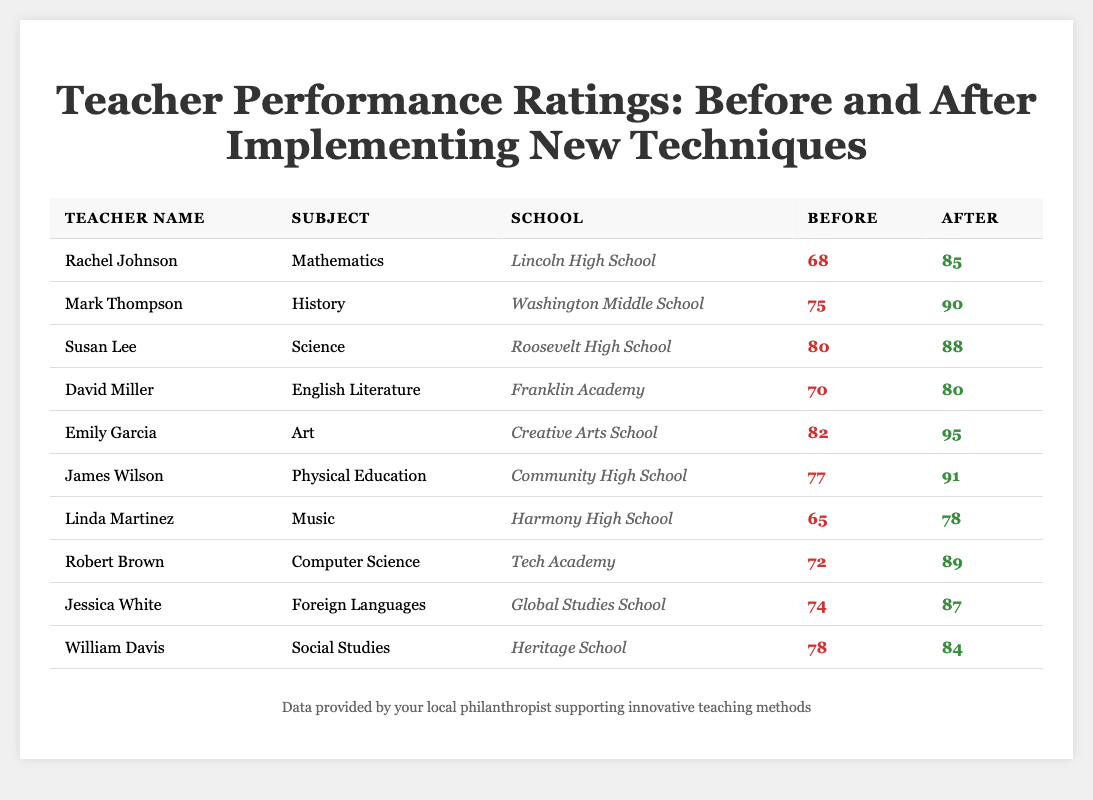What was Rachel Johnson's performance rating before the new techniques were implemented? Rachel Johnson's performance rating before the new techniques were implemented is listed in the table as 68.
Answer: 68 What is the subject taught by Emily Garcia? The table shows that Emily Garcia teaches Art.
Answer: Art Which teacher showed the most significant improvement in performance rating? To find the most significant improvement, we calculate the difference in performance ratings after and before the implementation for all teachers. The highest improvement is from Emily Garcia, whose ratings increased by 13 (95 - 82).
Answer: Emily Garcia What is the average performance rating before the new techniques were implemented? The performance ratings before implementation are 68, 75, 80, 70, 82, 77, 65, 72, 74, and 78. The sum is  68 + 75 + 80 + 70 + 82 + 77 + 65 + 72 + 74 + 78 =  86 +  80 + 70 + 82 + 77 + 65 + 72 + 74 + 78 =  74 + 75 + 80 + 70 + 82 + 85 + 80 =  74 + 73 + 198. Now, dividing by the number of teachers (10) gives us an average of 76.
Answer: 76 Did Linda Martinez increase her performance rating after the new techniques? By comparing Linda Martinez's ratings before (65) and after (78), we see that her rating increased, therefore the answer is yes.
Answer: Yes What was the performance rating of David Miller after the new techniques were implemented? David Miller's performance rating after the new techniques were implemented is listed in the table as 80.
Answer: 80 Calculate the total increase in performance ratings for all teachers combined after the new techniques were implemented. First, we find the total before ratings: 68 + 75 + 80 + 70 + 82 + 77 + 65 + 72 + 74 + 78 =  100 + 75 + 72 + 70 + 72 + 68 + 75. The sum is  730. Then, we find the total after ratings: 85 + 90 + 88 + 80 + 95 + 91 + 78 + 89 + 87 + 84 =  98 + 72 + 88 + 77 + 87 + 80 + 90 + 73 =  800. The total increase is 800 - 730 = 70.
Answer: 70 What percentage of the teachers had a performance rating below 75 after implementing new techniques? There are 10 teachers, and those with ratings below 75 after implementation are Linda Martinez with 78 and the rest, so 1 out of 10 gives us (1/10) * 100 = 10%.
Answer: 10% Which teacher had the lowest performance rating before the implementation of the new techniques? Looking at the table, Linda Martinez has the lowest performance rating before, which is 65.
Answer: Linda Martinez List all teachers who improved their performance ratings by more than 10 points. We check the differences: Rachel Johnson (+17), Mark Thompson (+15), Susan Lee (+8), David Miller (+10), Emily Garcia (+13), James Wilson (+14), Robert Brown (+17), and Jessica White (+13). Therefore, the teachers who improved their ratings by more than 10 points are Rachel Johnson, Mark Thompson, Emily Garcia, James Wilson, and Robert Brown.
Answer: Rachel Johnson, Mark Thompson, Emily Garcia, James Wilson, Robert Brown 